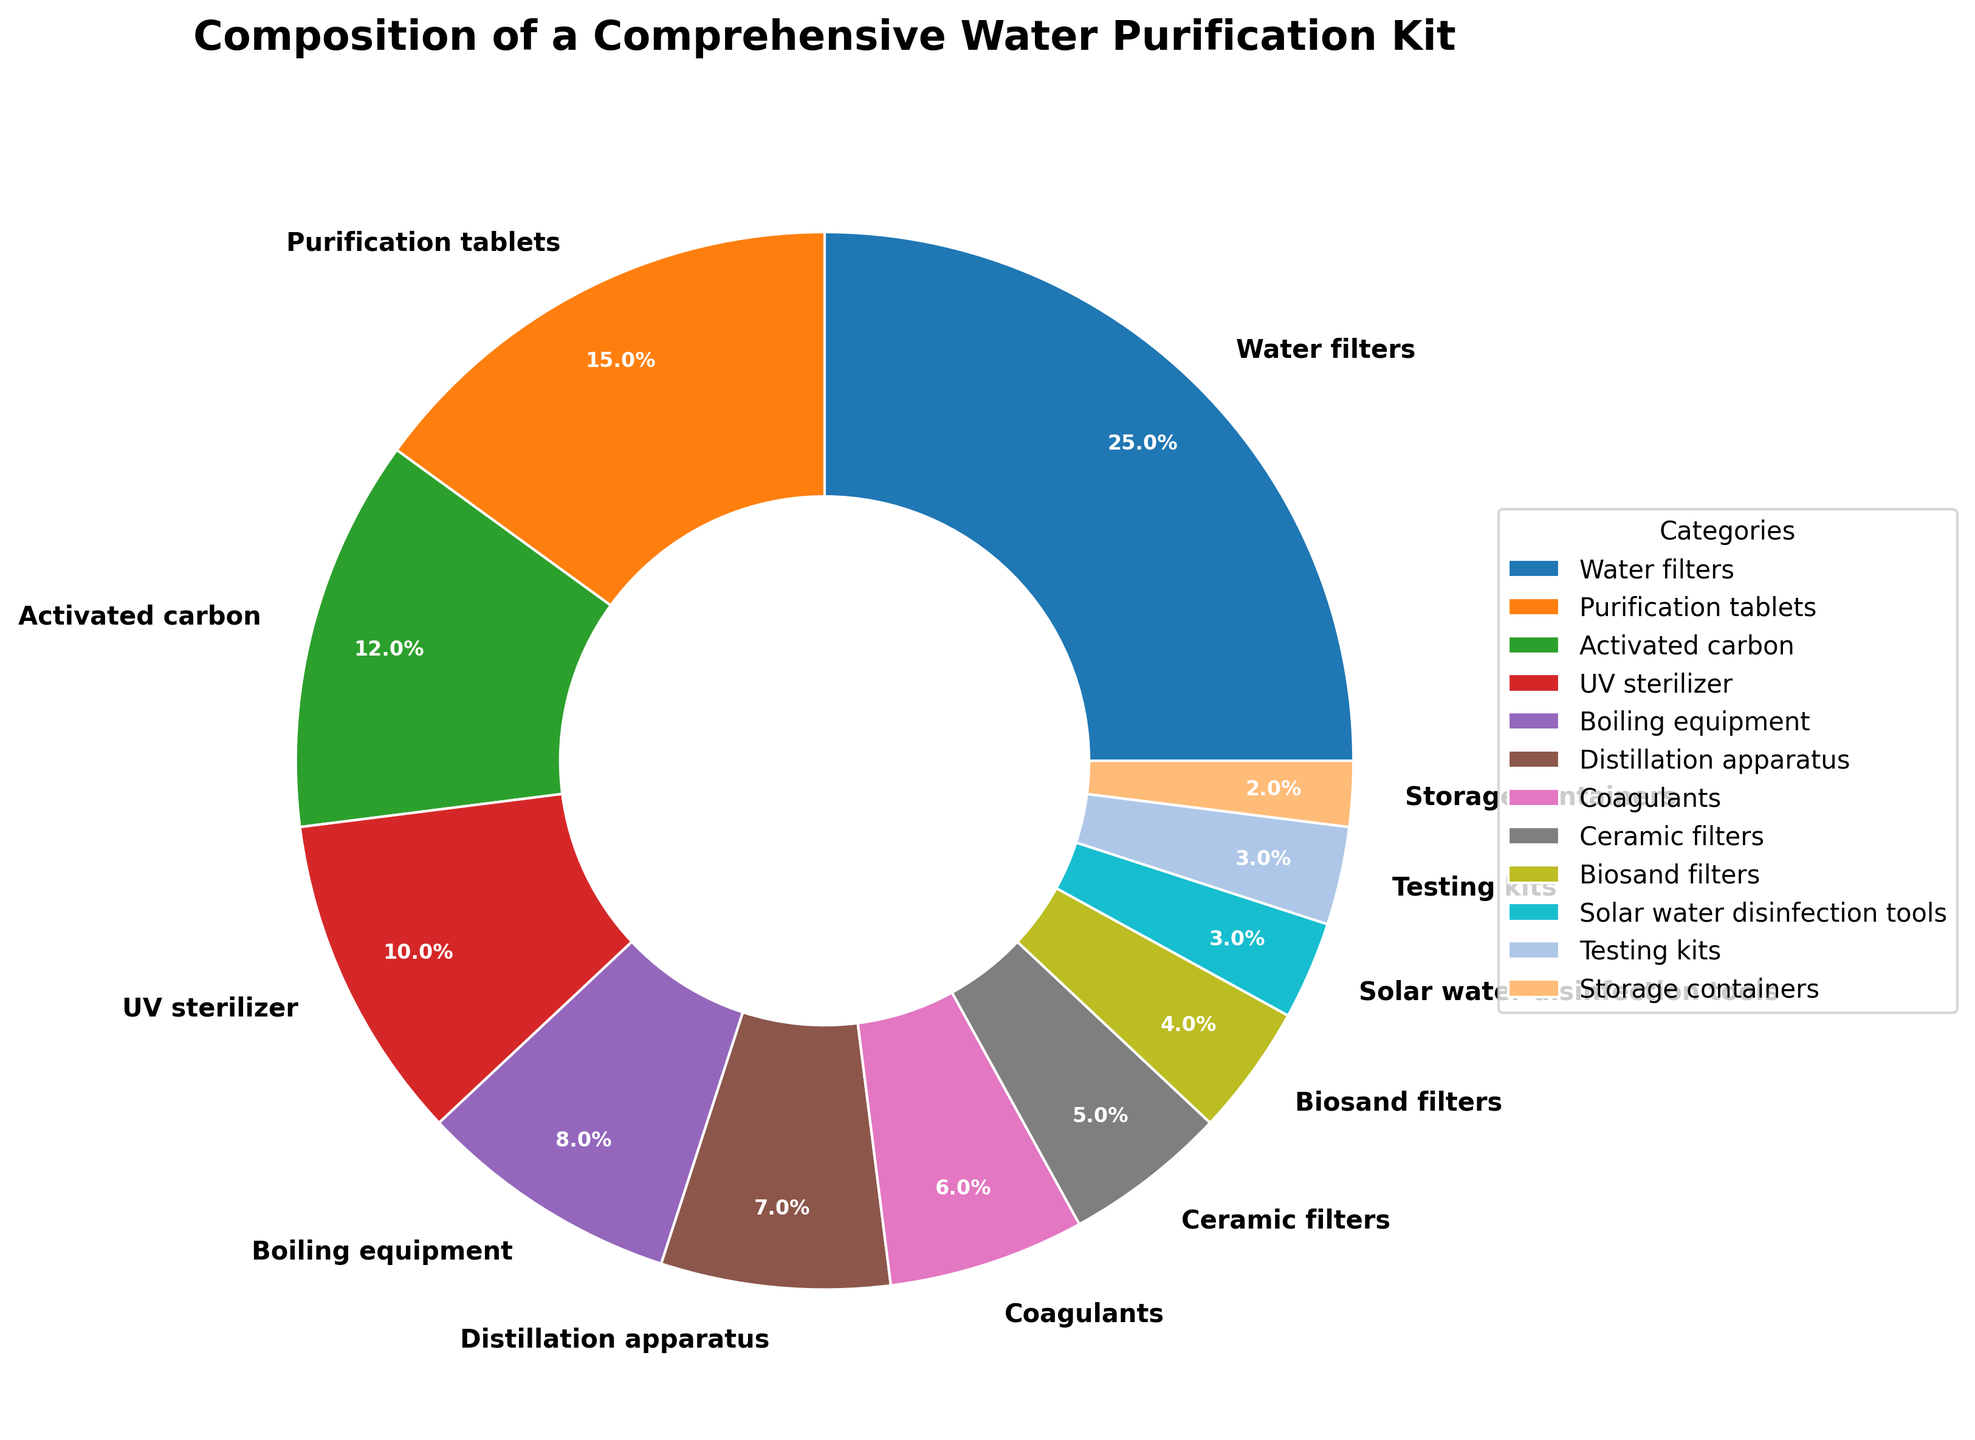What category takes up the largest portion of the pie chart? The largest portion is represented by the largest wedge in the chart, which is Water filters.
Answer: Water filters Which two categories together account for more than 30% of the composition? Sum the percentages for various pairs to find one that exceeds 30%. Water filters (25%) and Purification tablets (15%) together account for 40% of the composition.
Answer: Water filters and Purification tablets How much larger is the percentage of Water filters compared to the percentage of Ceramic filters? Subtract the percentage of Ceramic filters from the percentage of Water filters: 25% - 5% = 20%.
Answer: 20% Which category has the smallest portion in the pie chart? The smallest portion is represented by the smallest wedge in the chart, which is Storage containers.
Answer: Storage containers Is the combined percentage of Distillation apparatus and UV sterilizer larger than Water filters alone? Add the percentages of Distillation apparatus (7%) and UV sterilizer (10%) and compare with Water filters (25%): 7% + 10% = 17%. Since 17% < 25%, it is not larger.
Answer: No What is the total percentage of all categories related to filtering (Water filters, Ceramic filters, Biosand filters)? Sum the percentages of Water filters, Ceramic filters, and Biosand filters: 25% + 5% + 4% = 34%.
Answer: 34% Which category representing a more advanced purification method (UV sterilizer or Biosand filters) has a higher percentage? Compare the percentages of UV sterilizer (10%) and Biosand filters (4%). UV sterilizer has a higher percentage.
Answer: UV sterilizer How much of the composition is accounted for by less than 5% categories? Add the percentages of all categories below 5%: Biosand filters (4%) and Solar water disinfection tools (3%) = 4% + 3% = 7%.
Answer: 7% Among the categories listed, what is the percentage of storage-related components? Identify and sum the percentage of the storage-related category: Storage containers (2%). There's only one category related to storage.
Answer: 2% Are the combined percentages of Coagulants and Testing kits greater than that of Activated Carbon? Sum the percentages of Coagulants (6%) and Testing kits (3%) and compare with Activated Carbon (12%): 6% + 3% = 9%. Since 9% < 12%, it is not greater.
Answer: No 